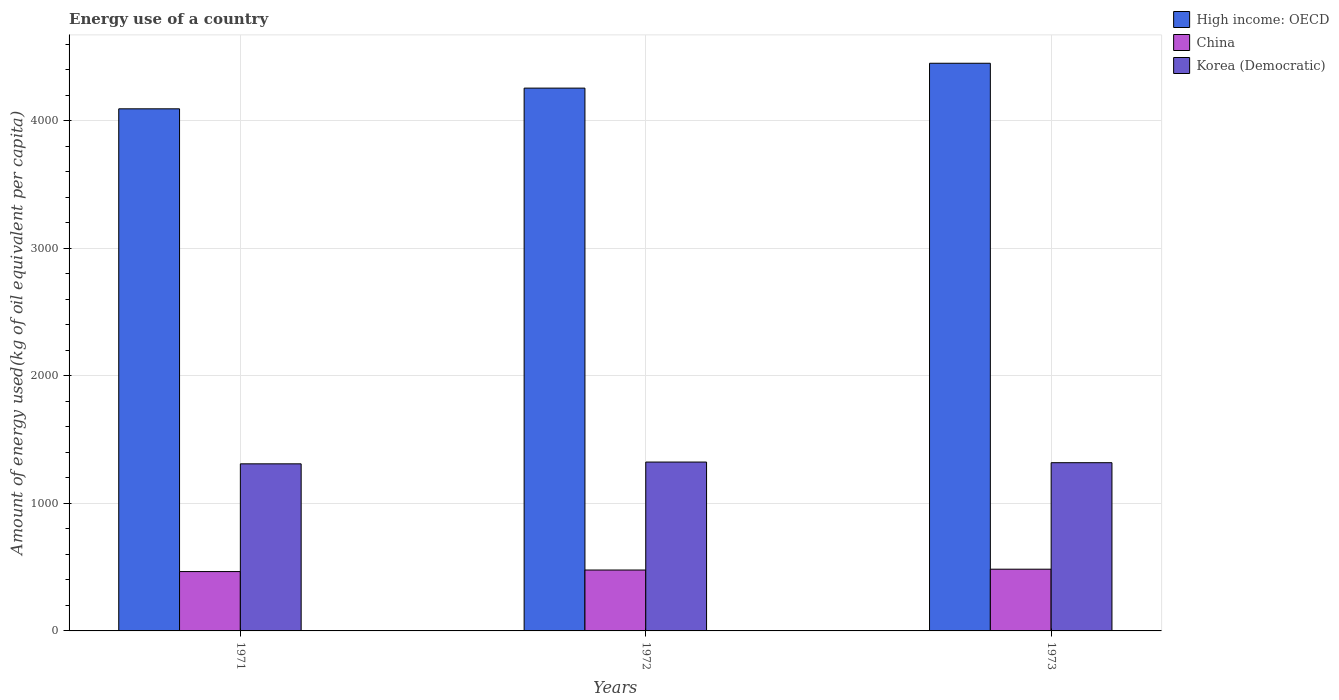How many different coloured bars are there?
Keep it short and to the point. 3. How many bars are there on the 3rd tick from the left?
Your answer should be very brief. 3. What is the label of the 3rd group of bars from the left?
Ensure brevity in your answer.  1973. In how many cases, is the number of bars for a given year not equal to the number of legend labels?
Ensure brevity in your answer.  0. What is the amount of energy used in in Korea (Democratic) in 1973?
Your answer should be compact. 1319.63. Across all years, what is the maximum amount of energy used in in High income: OECD?
Your answer should be very brief. 4452.86. Across all years, what is the minimum amount of energy used in in Korea (Democratic)?
Offer a terse response. 1310.63. In which year was the amount of energy used in in China maximum?
Ensure brevity in your answer.  1973. What is the total amount of energy used in in Korea (Democratic) in the graph?
Offer a very short reply. 3954.85. What is the difference between the amount of energy used in in China in 1971 and that in 1973?
Ensure brevity in your answer.  -18.73. What is the difference between the amount of energy used in in High income: OECD in 1972 and the amount of energy used in in Korea (Democratic) in 1971?
Keep it short and to the point. 2947.21. What is the average amount of energy used in in Korea (Democratic) per year?
Make the answer very short. 1318.28. In the year 1971, what is the difference between the amount of energy used in in Korea (Democratic) and amount of energy used in in China?
Make the answer very short. 845.11. In how many years, is the amount of energy used in in Korea (Democratic) greater than 4400 kg?
Ensure brevity in your answer.  0. What is the ratio of the amount of energy used in in Korea (Democratic) in 1972 to that in 1973?
Offer a very short reply. 1. Is the difference between the amount of energy used in in Korea (Democratic) in 1972 and 1973 greater than the difference between the amount of energy used in in China in 1972 and 1973?
Ensure brevity in your answer.  Yes. What is the difference between the highest and the second highest amount of energy used in in China?
Make the answer very short. 6.59. What is the difference between the highest and the lowest amount of energy used in in China?
Your answer should be compact. 18.73. In how many years, is the amount of energy used in in Korea (Democratic) greater than the average amount of energy used in in Korea (Democratic) taken over all years?
Your answer should be compact. 2. Is the sum of the amount of energy used in in Korea (Democratic) in 1972 and 1973 greater than the maximum amount of energy used in in China across all years?
Your answer should be compact. Yes. What does the 1st bar from the left in 1971 represents?
Keep it short and to the point. High income: OECD. What does the 2nd bar from the right in 1973 represents?
Give a very brief answer. China. What is the difference between two consecutive major ticks on the Y-axis?
Keep it short and to the point. 1000. Are the values on the major ticks of Y-axis written in scientific E-notation?
Your answer should be very brief. No. Does the graph contain any zero values?
Provide a short and direct response. No. Does the graph contain grids?
Keep it short and to the point. Yes. Where does the legend appear in the graph?
Offer a very short reply. Top right. How are the legend labels stacked?
Your answer should be compact. Vertical. What is the title of the graph?
Offer a very short reply. Energy use of a country. What is the label or title of the Y-axis?
Give a very brief answer. Amount of energy used(kg of oil equivalent per capita). What is the Amount of energy used(kg of oil equivalent per capita) of High income: OECD in 1971?
Provide a succinct answer. 4095.4. What is the Amount of energy used(kg of oil equivalent per capita) in China in 1971?
Keep it short and to the point. 465.52. What is the Amount of energy used(kg of oil equivalent per capita) of Korea (Democratic) in 1971?
Provide a succinct answer. 1310.63. What is the Amount of energy used(kg of oil equivalent per capita) in High income: OECD in 1972?
Offer a terse response. 4257.84. What is the Amount of energy used(kg of oil equivalent per capita) in China in 1972?
Your answer should be very brief. 477.66. What is the Amount of energy used(kg of oil equivalent per capita) of Korea (Democratic) in 1972?
Make the answer very short. 1324.59. What is the Amount of energy used(kg of oil equivalent per capita) of High income: OECD in 1973?
Offer a very short reply. 4452.86. What is the Amount of energy used(kg of oil equivalent per capita) of China in 1973?
Give a very brief answer. 484.25. What is the Amount of energy used(kg of oil equivalent per capita) in Korea (Democratic) in 1973?
Make the answer very short. 1319.63. Across all years, what is the maximum Amount of energy used(kg of oil equivalent per capita) of High income: OECD?
Provide a short and direct response. 4452.86. Across all years, what is the maximum Amount of energy used(kg of oil equivalent per capita) of China?
Your answer should be compact. 484.25. Across all years, what is the maximum Amount of energy used(kg of oil equivalent per capita) in Korea (Democratic)?
Keep it short and to the point. 1324.59. Across all years, what is the minimum Amount of energy used(kg of oil equivalent per capita) in High income: OECD?
Ensure brevity in your answer.  4095.4. Across all years, what is the minimum Amount of energy used(kg of oil equivalent per capita) of China?
Your response must be concise. 465.52. Across all years, what is the minimum Amount of energy used(kg of oil equivalent per capita) in Korea (Democratic)?
Your response must be concise. 1310.63. What is the total Amount of energy used(kg of oil equivalent per capita) of High income: OECD in the graph?
Keep it short and to the point. 1.28e+04. What is the total Amount of energy used(kg of oil equivalent per capita) of China in the graph?
Ensure brevity in your answer.  1427.43. What is the total Amount of energy used(kg of oil equivalent per capita) of Korea (Democratic) in the graph?
Offer a terse response. 3954.85. What is the difference between the Amount of energy used(kg of oil equivalent per capita) of High income: OECD in 1971 and that in 1972?
Keep it short and to the point. -162.44. What is the difference between the Amount of energy used(kg of oil equivalent per capita) of China in 1971 and that in 1972?
Give a very brief answer. -12.14. What is the difference between the Amount of energy used(kg of oil equivalent per capita) in Korea (Democratic) in 1971 and that in 1972?
Your response must be concise. -13.96. What is the difference between the Amount of energy used(kg of oil equivalent per capita) in High income: OECD in 1971 and that in 1973?
Ensure brevity in your answer.  -357.45. What is the difference between the Amount of energy used(kg of oil equivalent per capita) of China in 1971 and that in 1973?
Provide a succinct answer. -18.73. What is the difference between the Amount of energy used(kg of oil equivalent per capita) of Korea (Democratic) in 1971 and that in 1973?
Make the answer very short. -9. What is the difference between the Amount of energy used(kg of oil equivalent per capita) in High income: OECD in 1972 and that in 1973?
Give a very brief answer. -195.02. What is the difference between the Amount of energy used(kg of oil equivalent per capita) in China in 1972 and that in 1973?
Offer a very short reply. -6.59. What is the difference between the Amount of energy used(kg of oil equivalent per capita) in Korea (Democratic) in 1972 and that in 1973?
Your answer should be very brief. 4.97. What is the difference between the Amount of energy used(kg of oil equivalent per capita) in High income: OECD in 1971 and the Amount of energy used(kg of oil equivalent per capita) in China in 1972?
Make the answer very short. 3617.74. What is the difference between the Amount of energy used(kg of oil equivalent per capita) in High income: OECD in 1971 and the Amount of energy used(kg of oil equivalent per capita) in Korea (Democratic) in 1972?
Keep it short and to the point. 2770.81. What is the difference between the Amount of energy used(kg of oil equivalent per capita) of China in 1971 and the Amount of energy used(kg of oil equivalent per capita) of Korea (Democratic) in 1972?
Keep it short and to the point. -859.07. What is the difference between the Amount of energy used(kg of oil equivalent per capita) in High income: OECD in 1971 and the Amount of energy used(kg of oil equivalent per capita) in China in 1973?
Keep it short and to the point. 3611.16. What is the difference between the Amount of energy used(kg of oil equivalent per capita) in High income: OECD in 1971 and the Amount of energy used(kg of oil equivalent per capita) in Korea (Democratic) in 1973?
Give a very brief answer. 2775.78. What is the difference between the Amount of energy used(kg of oil equivalent per capita) in China in 1971 and the Amount of energy used(kg of oil equivalent per capita) in Korea (Democratic) in 1973?
Offer a terse response. -854.11. What is the difference between the Amount of energy used(kg of oil equivalent per capita) of High income: OECD in 1972 and the Amount of energy used(kg of oil equivalent per capita) of China in 1973?
Ensure brevity in your answer.  3773.59. What is the difference between the Amount of energy used(kg of oil equivalent per capita) of High income: OECD in 1972 and the Amount of energy used(kg of oil equivalent per capita) of Korea (Democratic) in 1973?
Your answer should be very brief. 2938.22. What is the difference between the Amount of energy used(kg of oil equivalent per capita) of China in 1972 and the Amount of energy used(kg of oil equivalent per capita) of Korea (Democratic) in 1973?
Make the answer very short. -841.96. What is the average Amount of energy used(kg of oil equivalent per capita) in High income: OECD per year?
Give a very brief answer. 4268.7. What is the average Amount of energy used(kg of oil equivalent per capita) in China per year?
Provide a succinct answer. 475.81. What is the average Amount of energy used(kg of oil equivalent per capita) of Korea (Democratic) per year?
Your answer should be very brief. 1318.28. In the year 1971, what is the difference between the Amount of energy used(kg of oil equivalent per capita) in High income: OECD and Amount of energy used(kg of oil equivalent per capita) in China?
Provide a short and direct response. 3629.88. In the year 1971, what is the difference between the Amount of energy used(kg of oil equivalent per capita) in High income: OECD and Amount of energy used(kg of oil equivalent per capita) in Korea (Democratic)?
Keep it short and to the point. 2784.78. In the year 1971, what is the difference between the Amount of energy used(kg of oil equivalent per capita) in China and Amount of energy used(kg of oil equivalent per capita) in Korea (Democratic)?
Your response must be concise. -845.11. In the year 1972, what is the difference between the Amount of energy used(kg of oil equivalent per capita) of High income: OECD and Amount of energy used(kg of oil equivalent per capita) of China?
Your answer should be very brief. 3780.18. In the year 1972, what is the difference between the Amount of energy used(kg of oil equivalent per capita) in High income: OECD and Amount of energy used(kg of oil equivalent per capita) in Korea (Democratic)?
Give a very brief answer. 2933.25. In the year 1972, what is the difference between the Amount of energy used(kg of oil equivalent per capita) of China and Amount of energy used(kg of oil equivalent per capita) of Korea (Democratic)?
Your answer should be compact. -846.93. In the year 1973, what is the difference between the Amount of energy used(kg of oil equivalent per capita) in High income: OECD and Amount of energy used(kg of oil equivalent per capita) in China?
Your answer should be very brief. 3968.61. In the year 1973, what is the difference between the Amount of energy used(kg of oil equivalent per capita) in High income: OECD and Amount of energy used(kg of oil equivalent per capita) in Korea (Democratic)?
Keep it short and to the point. 3133.23. In the year 1973, what is the difference between the Amount of energy used(kg of oil equivalent per capita) of China and Amount of energy used(kg of oil equivalent per capita) of Korea (Democratic)?
Give a very brief answer. -835.38. What is the ratio of the Amount of energy used(kg of oil equivalent per capita) in High income: OECD in 1971 to that in 1972?
Your response must be concise. 0.96. What is the ratio of the Amount of energy used(kg of oil equivalent per capita) of China in 1971 to that in 1972?
Provide a succinct answer. 0.97. What is the ratio of the Amount of energy used(kg of oil equivalent per capita) of Korea (Democratic) in 1971 to that in 1972?
Provide a short and direct response. 0.99. What is the ratio of the Amount of energy used(kg of oil equivalent per capita) of High income: OECD in 1971 to that in 1973?
Provide a short and direct response. 0.92. What is the ratio of the Amount of energy used(kg of oil equivalent per capita) of China in 1971 to that in 1973?
Keep it short and to the point. 0.96. What is the ratio of the Amount of energy used(kg of oil equivalent per capita) of High income: OECD in 1972 to that in 1973?
Make the answer very short. 0.96. What is the ratio of the Amount of energy used(kg of oil equivalent per capita) of China in 1972 to that in 1973?
Your response must be concise. 0.99. What is the ratio of the Amount of energy used(kg of oil equivalent per capita) in Korea (Democratic) in 1972 to that in 1973?
Give a very brief answer. 1. What is the difference between the highest and the second highest Amount of energy used(kg of oil equivalent per capita) in High income: OECD?
Keep it short and to the point. 195.02. What is the difference between the highest and the second highest Amount of energy used(kg of oil equivalent per capita) of China?
Your response must be concise. 6.59. What is the difference between the highest and the second highest Amount of energy used(kg of oil equivalent per capita) of Korea (Democratic)?
Offer a terse response. 4.97. What is the difference between the highest and the lowest Amount of energy used(kg of oil equivalent per capita) of High income: OECD?
Offer a terse response. 357.45. What is the difference between the highest and the lowest Amount of energy used(kg of oil equivalent per capita) of China?
Your answer should be very brief. 18.73. What is the difference between the highest and the lowest Amount of energy used(kg of oil equivalent per capita) of Korea (Democratic)?
Ensure brevity in your answer.  13.96. 